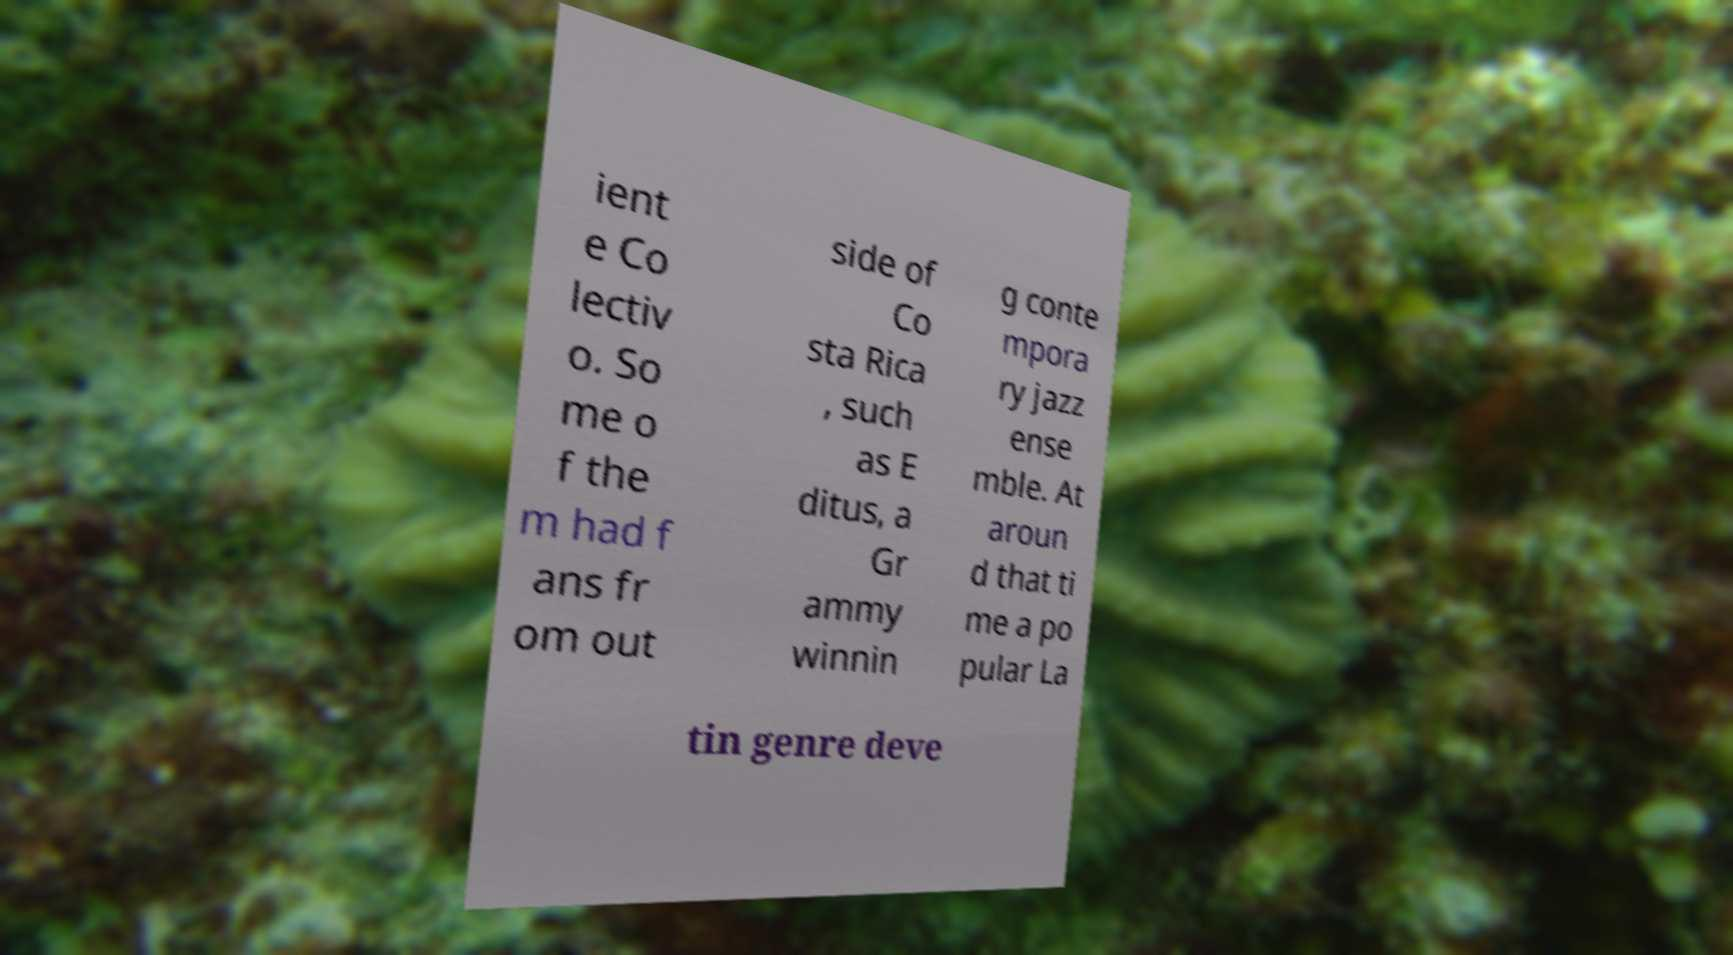Can you read and provide the text displayed in the image?This photo seems to have some interesting text. Can you extract and type it out for me? ient e Co lectiv o. So me o f the m had f ans fr om out side of Co sta Rica , such as E ditus, a Gr ammy winnin g conte mpora ry jazz ense mble. At aroun d that ti me a po pular La tin genre deve 